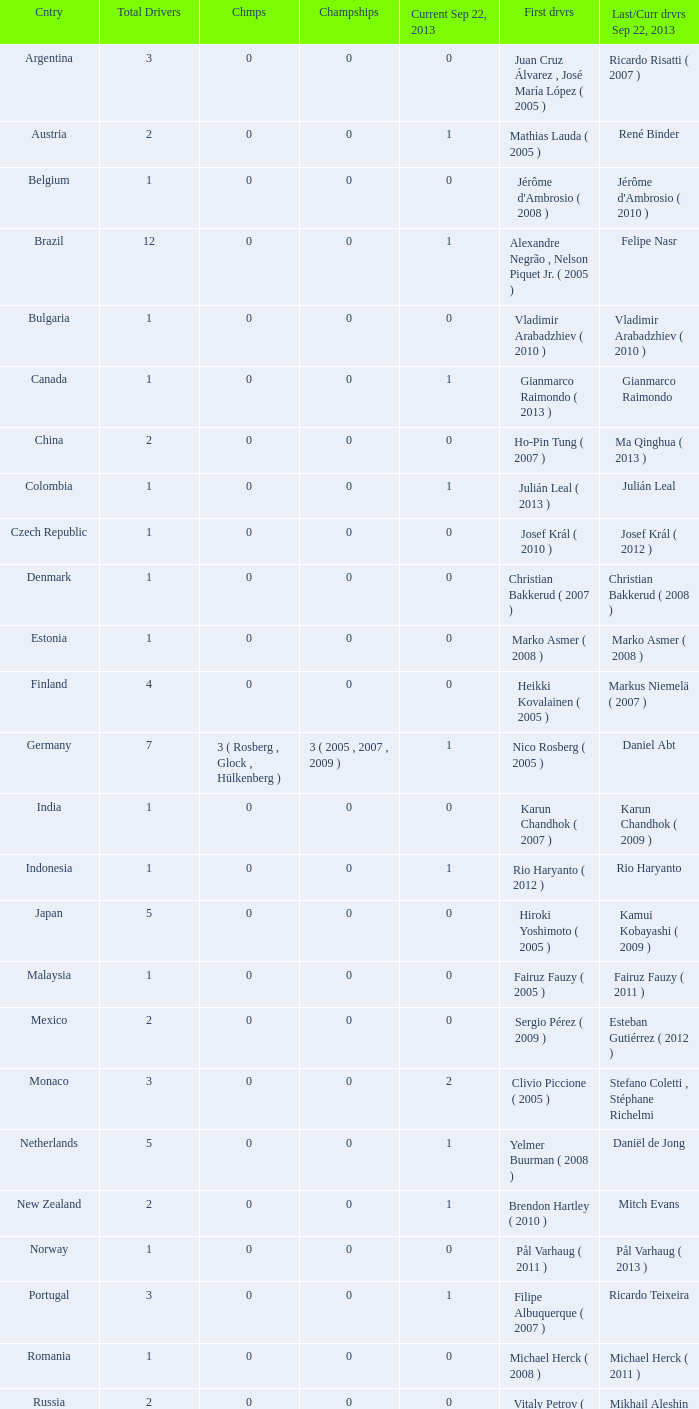Parse the table in full. {'header': ['Cntry', 'Total Drivers', 'Chmps', 'Champships', 'Current Sep 22, 2013', 'First drvrs', 'Last/Curr drvrs Sep 22, 2013'], 'rows': [['Argentina', '3', '0', '0', '0', 'Juan Cruz Álvarez , José María López ( 2005 )', 'Ricardo Risatti ( 2007 )'], ['Austria', '2', '0', '0', '1', 'Mathias Lauda ( 2005 )', 'René Binder'], ['Belgium', '1', '0', '0', '0', "Jérôme d'Ambrosio ( 2008 )", "Jérôme d'Ambrosio ( 2010 )"], ['Brazil', '12', '0', '0', '1', 'Alexandre Negrão , Nelson Piquet Jr. ( 2005 )', 'Felipe Nasr'], ['Bulgaria', '1', '0', '0', '0', 'Vladimir Arabadzhiev ( 2010 )', 'Vladimir Arabadzhiev ( 2010 )'], ['Canada', '1', '0', '0', '1', 'Gianmarco Raimondo ( 2013 )', 'Gianmarco Raimondo'], ['China', '2', '0', '0', '0', 'Ho-Pin Tung ( 2007 )', 'Ma Qinghua ( 2013 )'], ['Colombia', '1', '0', '0', '1', 'Julián Leal ( 2013 )', 'Julián Leal'], ['Czech Republic', '1', '0', '0', '0', 'Josef Král ( 2010 )', 'Josef Král ( 2012 )'], ['Denmark', '1', '0', '0', '0', 'Christian Bakkerud ( 2007 )', 'Christian Bakkerud ( 2008 )'], ['Estonia', '1', '0', '0', '0', 'Marko Asmer ( 2008 )', 'Marko Asmer ( 2008 )'], ['Finland', '4', '0', '0', '0', 'Heikki Kovalainen ( 2005 )', 'Markus Niemelä ( 2007 )'], ['Germany', '7', '3 ( Rosberg , Glock , Hülkenberg )', '3 ( 2005 , 2007 , 2009 )', '1', 'Nico Rosberg ( 2005 )', 'Daniel Abt'], ['India', '1', '0', '0', '0', 'Karun Chandhok ( 2007 )', 'Karun Chandhok ( 2009 )'], ['Indonesia', '1', '0', '0', '1', 'Rio Haryanto ( 2012 )', 'Rio Haryanto'], ['Japan', '5', '0', '0', '0', 'Hiroki Yoshimoto ( 2005 )', 'Kamui Kobayashi ( 2009 )'], ['Malaysia', '1', '0', '0', '0', 'Fairuz Fauzy ( 2005 )', 'Fairuz Fauzy ( 2011 )'], ['Mexico', '2', '0', '0', '0', 'Sergio Pérez ( 2009 )', 'Esteban Gutiérrez ( 2012 )'], ['Monaco', '3', '0', '0', '2', 'Clivio Piccione ( 2005 )', 'Stefano Coletti , Stéphane Richelmi'], ['Netherlands', '5', '0', '0', '1', 'Yelmer Buurman ( 2008 )', 'Daniël de Jong'], ['New Zealand', '2', '0', '0', '1', 'Brendon Hartley ( 2010 )', 'Mitch Evans'], ['Norway', '1', '0', '0', '0', 'Pål Varhaug ( 2011 )', 'Pål Varhaug ( 2013 )'], ['Portugal', '3', '0', '0', '1', 'Filipe Albuquerque ( 2007 )', 'Ricardo Teixeira'], ['Romania', '1', '0', '0', '0', 'Michael Herck ( 2008 )', 'Michael Herck ( 2011 )'], ['Russia', '2', '0', '0', '0', 'Vitaly Petrov ( 2006 )', 'Mikhail Aleshin ( 2011 )'], ['Serbia', '1', '0', '0', '0', 'Miloš Pavlović ( 2008 )', 'Miloš Pavlović ( 2008 )'], ['South Africa', '1', '0', '0', '0', 'Adrian Zaugg ( 2007 )', 'Adrian Zaugg ( 2010 )'], ['Spain', '10', '0', '0', '2', 'Borja García , Sergio Hernández ( 2005 )', 'Sergio Canamasas , Dani Clos'], ['Sweden', '1', '0', '0', '1', 'Marcus Ericsson ( 2010 )', 'Marcus Ericsson'], ['Switzerland', '5', '0', '0', '2', 'Neel Jani ( 2005 )', 'Fabio Leimer , Simon Trummer'], ['Turkey', '2', '0', '0', '0', 'Can Artam ( 2005 )', 'Jason Tahincioglu ( 2007 )'], ['United Arab Emirates', '1', '0', '0', '0', 'Andreas Zuber ( 2006 )', 'Andreas Zuber ( 2009 )'], ['United States', '4', '0', '0', '2', 'Scott Speed ( 2005 )', 'Jake Rosenzweig , Alexander Rossi']]} How many champions were there when the last driver for September 22, 2013 was vladimir arabadzhiev ( 2010 )? 0.0. 